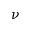<formula> <loc_0><loc_0><loc_500><loc_500>\nu</formula> 